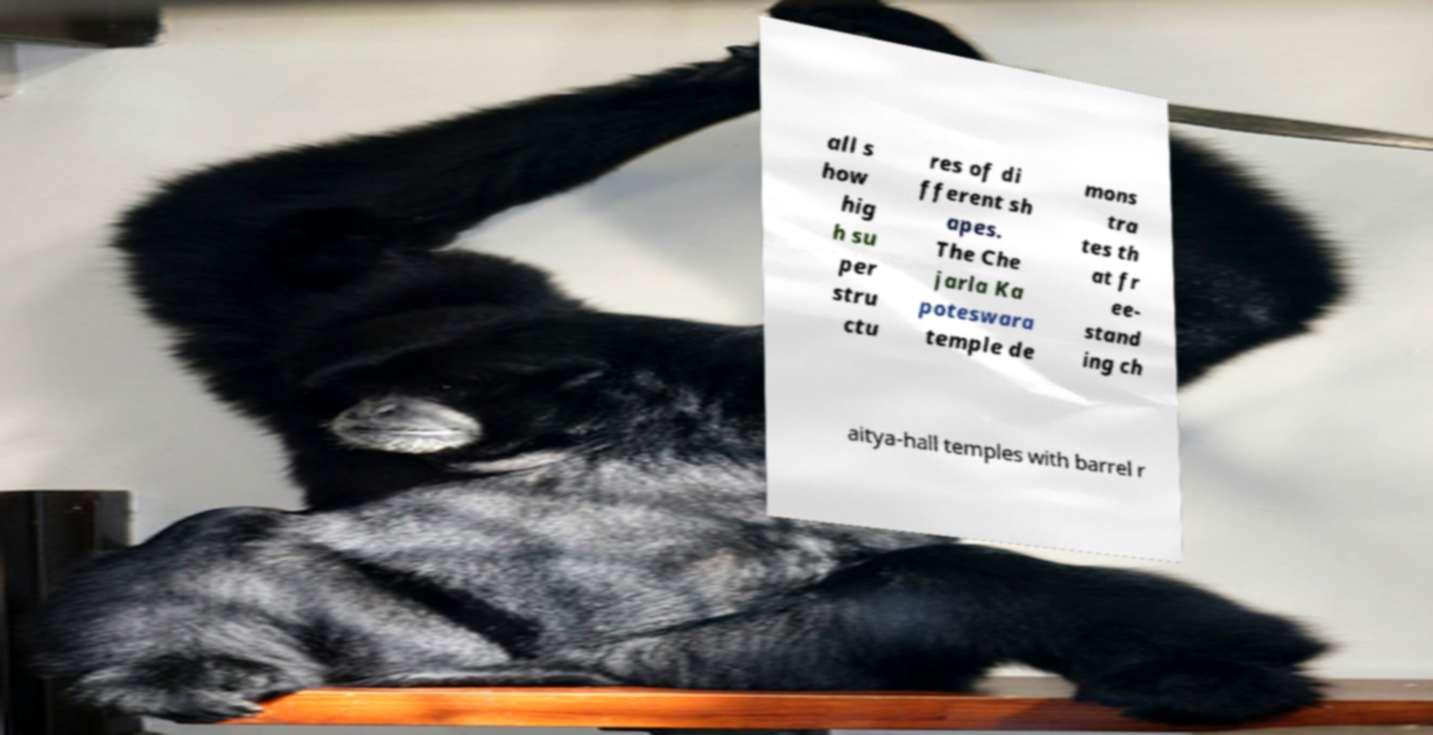Could you assist in decoding the text presented in this image and type it out clearly? all s how hig h su per stru ctu res of di fferent sh apes. The Che jarla Ka poteswara temple de mons tra tes th at fr ee- stand ing ch aitya-hall temples with barrel r 